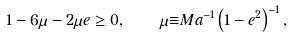<formula> <loc_0><loc_0><loc_500><loc_500>1 - 6 \mu - 2 { \mu } e \geq 0 , \quad \mu { \equiv } M a ^ { - 1 } \left ( 1 - e ^ { 2 } \right ) ^ { - 1 } ,</formula> 